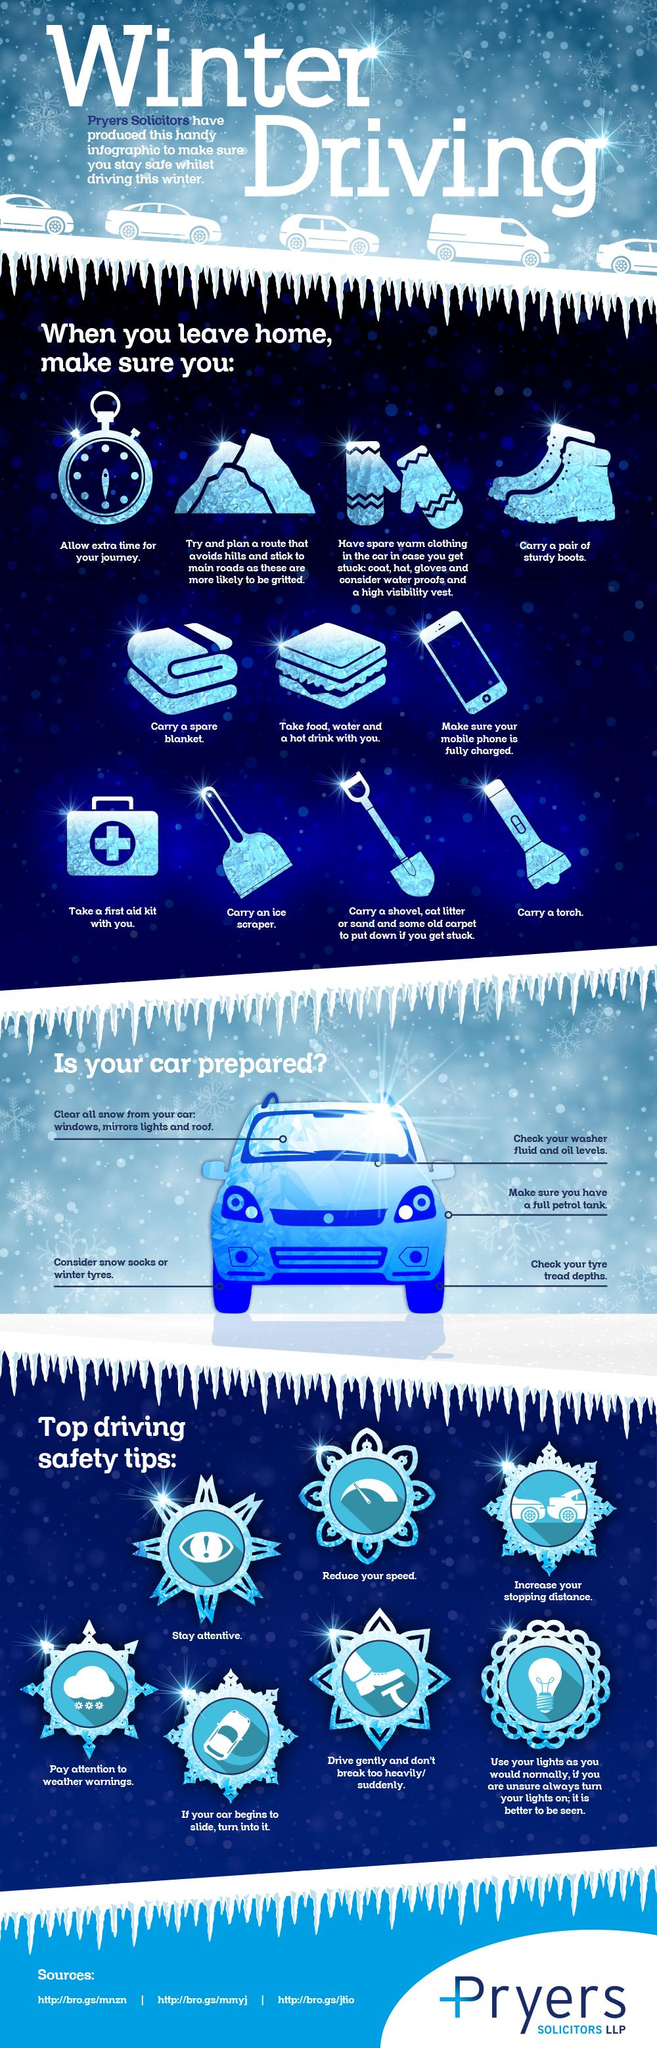Give some essential details in this illustration. In the safety tip, the exclamation mark is used to define the importance of staying attentive. Leaving home tips advise to factor in additional time for travel due to the indication of the clock. The climate being discussed is winter. When leaving home, it is important to ensure that your mobile phone is fully charged, as indicated by the mobile phone. It is necessary to address and address at least 5 points in order to ensure that your car is properly prepared. 